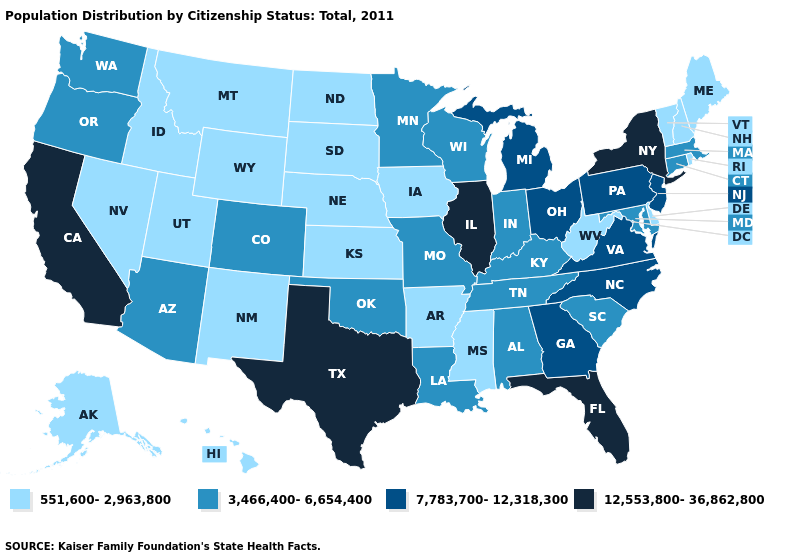Name the states that have a value in the range 3,466,400-6,654,400?
Short answer required. Alabama, Arizona, Colorado, Connecticut, Indiana, Kentucky, Louisiana, Maryland, Massachusetts, Minnesota, Missouri, Oklahoma, Oregon, South Carolina, Tennessee, Washington, Wisconsin. Which states hav the highest value in the South?
Answer briefly. Florida, Texas. Name the states that have a value in the range 7,783,700-12,318,300?
Quick response, please. Georgia, Michigan, New Jersey, North Carolina, Ohio, Pennsylvania, Virginia. What is the value of Nevada?
Quick response, please. 551,600-2,963,800. Name the states that have a value in the range 12,553,800-36,862,800?
Be succinct. California, Florida, Illinois, New York, Texas. Is the legend a continuous bar?
Give a very brief answer. No. What is the value of New Mexico?
Give a very brief answer. 551,600-2,963,800. Which states have the lowest value in the West?
Give a very brief answer. Alaska, Hawaii, Idaho, Montana, Nevada, New Mexico, Utah, Wyoming. Name the states that have a value in the range 12,553,800-36,862,800?
Short answer required. California, Florida, Illinois, New York, Texas. Name the states that have a value in the range 7,783,700-12,318,300?
Be succinct. Georgia, Michigan, New Jersey, North Carolina, Ohio, Pennsylvania, Virginia. Does Texas have the highest value in the USA?
Short answer required. Yes. What is the value of Vermont?
Concise answer only. 551,600-2,963,800. What is the value of Delaware?
Quick response, please. 551,600-2,963,800. What is the highest value in the West ?
Answer briefly. 12,553,800-36,862,800. What is the value of Mississippi?
Quick response, please. 551,600-2,963,800. 